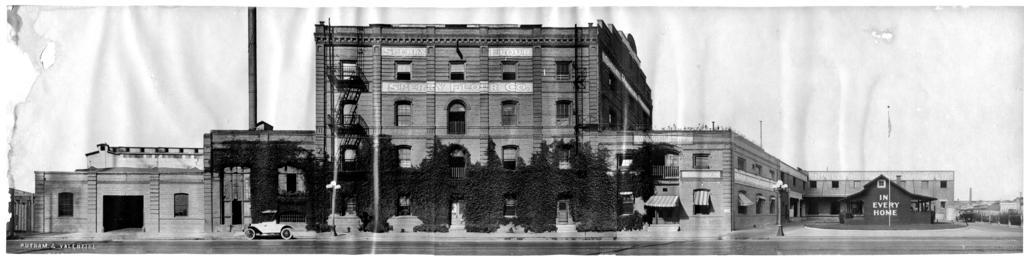Please provide a concise description of this image. In this picture we can see buildings and trees, there is a car here, we can see windows of this building, on the right side there is a pole and lights, it is a black and white picture, at the left bottom there is some text. 